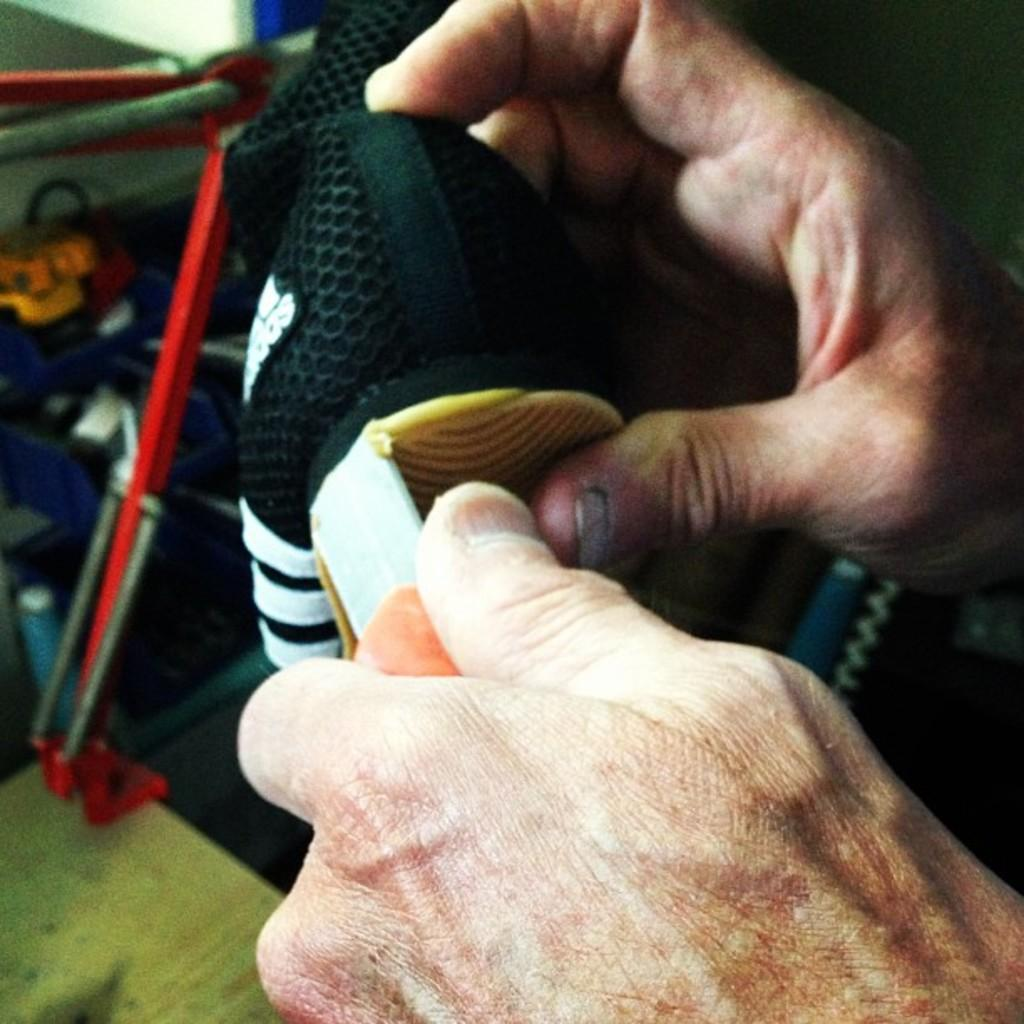What can be seen in the front of the image? There are hands of a person visible in the front of the image. What are the hands holding? The hands are holding an object that is black in color. What is visible in the background of the image? There is an object in the background of the image. What is the color of the object in the background? The object in the background is red in color. Can you tell me how many balls of yarn are being crushed by the hands in the image? There is no yarn or balls of yarn present in the image, and therefore no such activity can be observed. What type of basketball game is happening in the background of the image? There is no basketball game or any reference to a basketball in the image. 